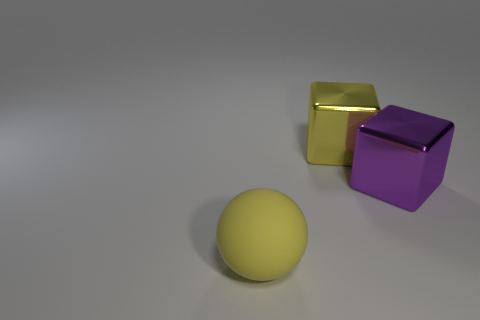Add 2 large yellow blocks. How many objects exist? 5 Subtract 1 spheres. How many spheres are left? 0 Subtract all balls. How many objects are left? 2 Subtract all yellow blocks. How many blocks are left? 1 Subtract all large purple metallic cubes. Subtract all big yellow metal things. How many objects are left? 1 Add 2 big matte objects. How many big matte objects are left? 3 Add 2 big gray matte cylinders. How many big gray matte cylinders exist? 2 Subtract 0 blue cubes. How many objects are left? 3 Subtract all yellow cubes. Subtract all green balls. How many cubes are left? 1 